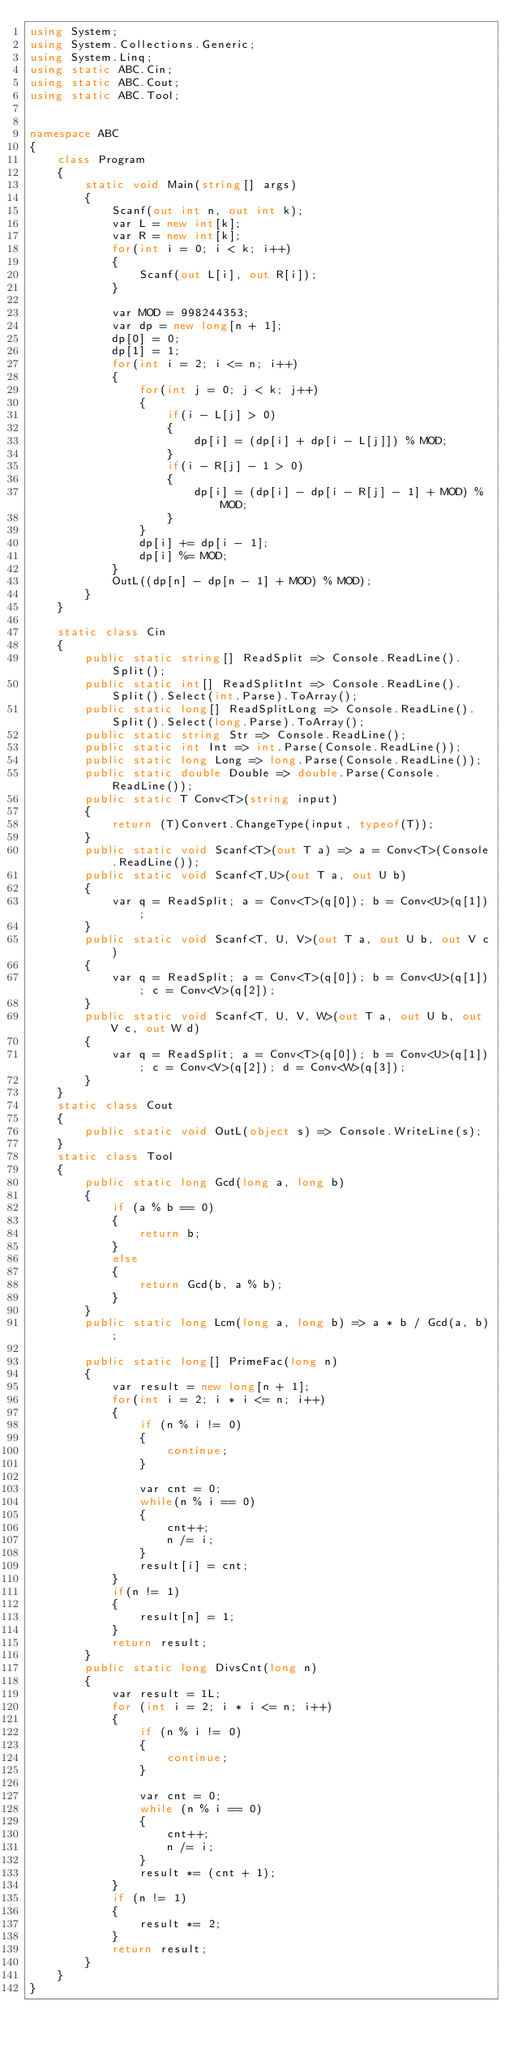Convert code to text. <code><loc_0><loc_0><loc_500><loc_500><_C#_>using System;
using System.Collections.Generic;
using System.Linq;
using static ABC.Cin;
using static ABC.Cout;
using static ABC.Tool;


namespace ABC
{
    class Program
    {
        static void Main(string[] args)
        {
            Scanf(out int n, out int k);
            var L = new int[k];
            var R = new int[k];
            for(int i = 0; i < k; i++)
            {
                Scanf(out L[i], out R[i]);
            }

            var MOD = 998244353;
            var dp = new long[n + 1];
            dp[0] = 0;
            dp[1] = 1;
            for(int i = 2; i <= n; i++)
            {
                for(int j = 0; j < k; j++)
                {
                    if(i - L[j] > 0)
                    {
                        dp[i] = (dp[i] + dp[i - L[j]]) % MOD;
                    }
                    if(i - R[j] - 1 > 0)
                    {
                        dp[i] = (dp[i] - dp[i - R[j] - 1] + MOD) % MOD;
                    }
                }
                dp[i] += dp[i - 1];
                dp[i] %= MOD;
            }
            OutL((dp[n] - dp[n - 1] + MOD) % MOD);
        }
    }

    static class Cin
    {
        public static string[] ReadSplit => Console.ReadLine().Split();
        public static int[] ReadSplitInt => Console.ReadLine().Split().Select(int.Parse).ToArray();
        public static long[] ReadSplitLong => Console.ReadLine().Split().Select(long.Parse).ToArray();
        public static string Str => Console.ReadLine();
        public static int Int => int.Parse(Console.ReadLine());
        public static long Long => long.Parse(Console.ReadLine());
        public static double Double => double.Parse(Console.ReadLine());
        public static T Conv<T>(string input)
        {
            return (T)Convert.ChangeType(input, typeof(T));
        }
        public static void Scanf<T>(out T a) => a = Conv<T>(Console.ReadLine());
        public static void Scanf<T,U>(out T a, out U b)
        {
            var q = ReadSplit; a = Conv<T>(q[0]); b = Conv<U>(q[1]);
        }
        public static void Scanf<T, U, V>(out T a, out U b, out V c)
        {
            var q = ReadSplit; a = Conv<T>(q[0]); b = Conv<U>(q[1]); c = Conv<V>(q[2]);
        }
        public static void Scanf<T, U, V, W>(out T a, out U b, out V c, out W d)
        {
            var q = ReadSplit; a = Conv<T>(q[0]); b = Conv<U>(q[1]); c = Conv<V>(q[2]); d = Conv<W>(q[3]);
        }
    }
    static class Cout
    {
        public static void OutL(object s) => Console.WriteLine(s);
    }
    static class Tool
    {
        public static long Gcd(long a, long b)
        {
            if (a % b == 0)
            {
                return b;
            }
            else
            {
                return Gcd(b, a % b);
            }
        }
        public static long Lcm(long a, long b) => a * b / Gcd(a, b);

        public static long[] PrimeFac(long n)
        {
            var result = new long[n + 1];
            for(int i = 2; i * i <= n; i++)
            {
                if (n % i != 0)
                {
                    continue;
                }

                var cnt = 0;
                while(n % i == 0)
                {
                    cnt++;
                    n /= i;
                }
                result[i] = cnt;
            }
            if(n != 1)
            {
                result[n] = 1;
            }
            return result;
        }
        public static long DivsCnt(long n)
        {
            var result = 1L;
            for (int i = 2; i * i <= n; i++)
            {
                if (n % i != 0)
                {
                    continue;
                }

                var cnt = 0;
                while (n % i == 0)
                {
                    cnt++;
                    n /= i;
                }
                result *= (cnt + 1);
            }
            if (n != 1)
            {
                result *= 2;
            }
            return result;
        }
    }
}</code> 